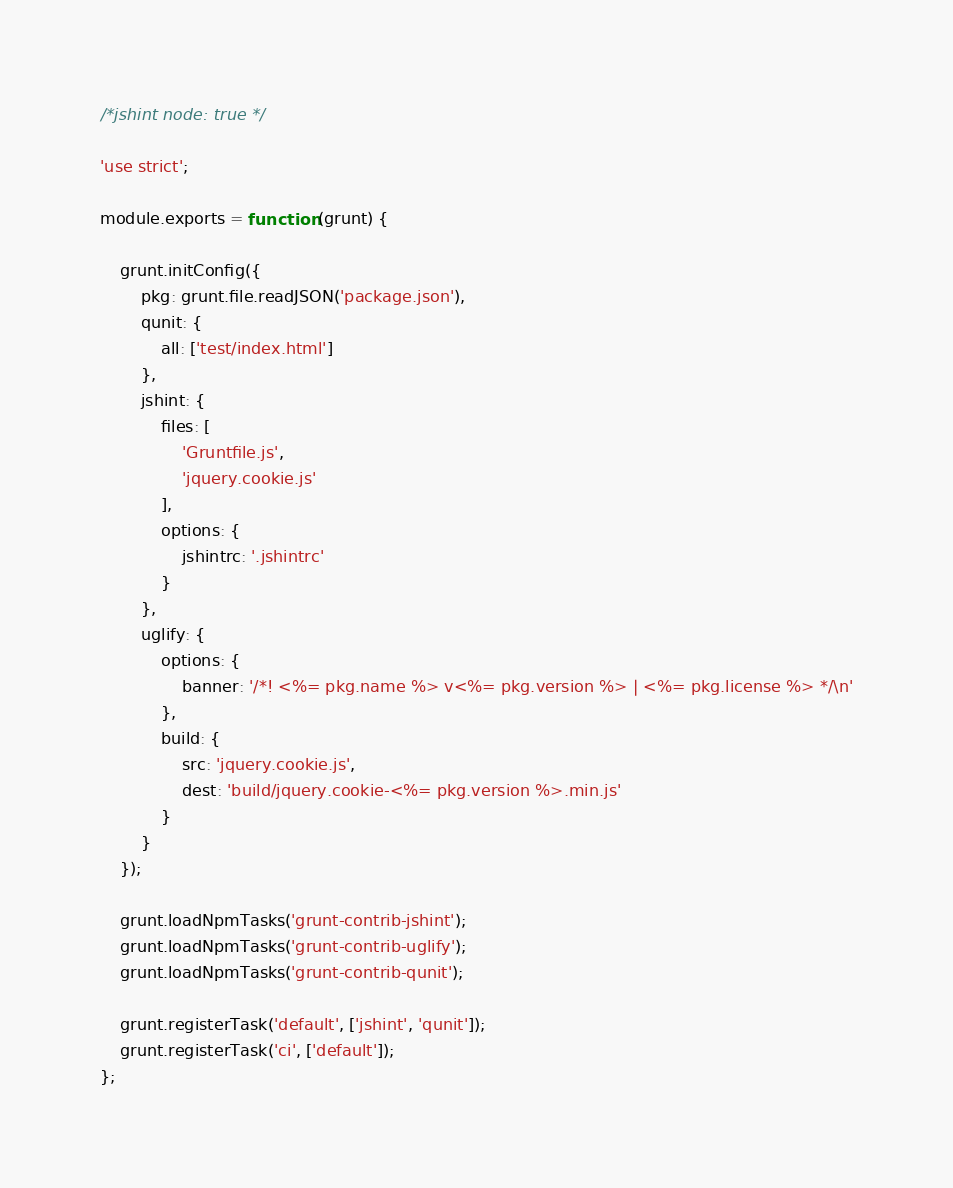<code> <loc_0><loc_0><loc_500><loc_500><_JavaScript_>/*jshint node: true */

'use strict';

module.exports = function (grunt) {

	grunt.initConfig({
		pkg: grunt.file.readJSON('package.json'),
		qunit: {
			all: ['test/index.html']
		},
		jshint: {
			files: [
				'Gruntfile.js',
				'jquery.cookie.js'
			],
			options: {
				jshintrc: '.jshintrc'
			}
		},
		uglify: {
			options: {
				banner: '/*! <%= pkg.name %> v<%= pkg.version %> | <%= pkg.license %> */\n'
			},
			build: {
				src: 'jquery.cookie.js',
				dest: 'build/jquery.cookie-<%= pkg.version %>.min.js'
			}
		}
	});

	grunt.loadNpmTasks('grunt-contrib-jshint');
	grunt.loadNpmTasks('grunt-contrib-uglify');
	grunt.loadNpmTasks('grunt-contrib-qunit');

	grunt.registerTask('default', ['jshint', 'qunit']);
	grunt.registerTask('ci', ['default']);
};
</code> 